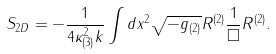<formula> <loc_0><loc_0><loc_500><loc_500>S _ { 2 D } = - \frac { 1 } { 4 \kappa _ { ( 3 ) } ^ { 2 } k } \int d x ^ { 2 } \sqrt { - g _ { ( 2 ) } } R ^ { ( 2 ) } \frac { 1 } { \Box } R ^ { ( 2 ) } .</formula> 